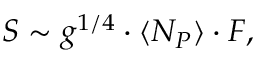<formula> <loc_0><loc_0><loc_500><loc_500>S \sim g ^ { 1 / 4 } \cdot \langle N _ { P } \rangle \cdot F ,</formula> 